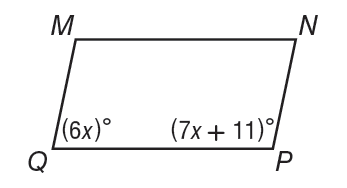Question: Parallelogram M N P Q is shown. What is the value of x?
Choices:
A. 13
B. 39
C. 141
D. 169
Answer with the letter. Answer: A 